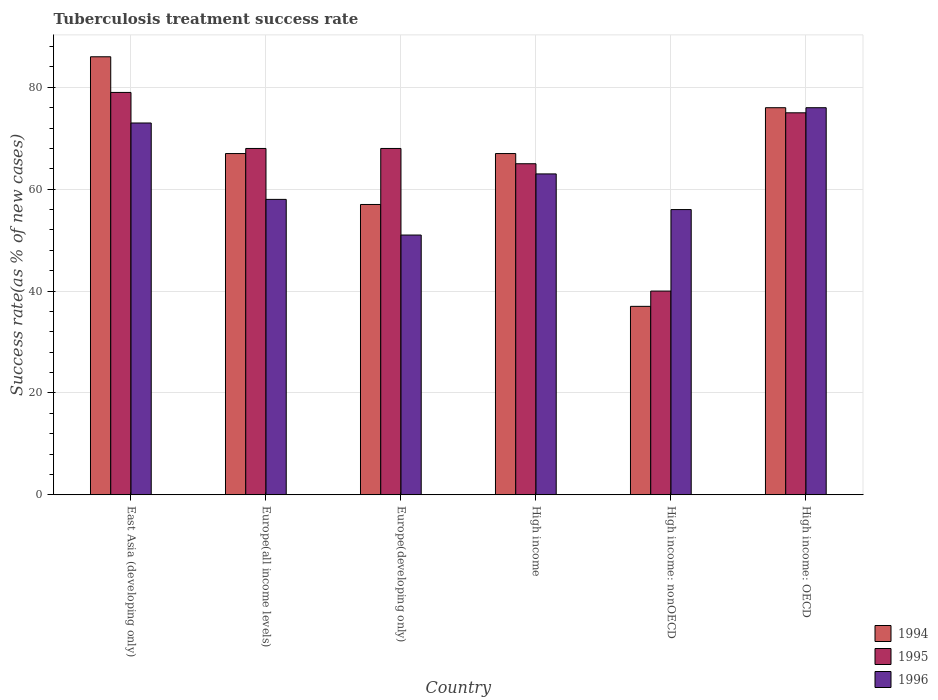How many different coloured bars are there?
Your response must be concise. 3. How many groups of bars are there?
Your response must be concise. 6. Are the number of bars per tick equal to the number of legend labels?
Your answer should be compact. Yes. What is the label of the 6th group of bars from the left?
Provide a short and direct response. High income: OECD. What is the tuberculosis treatment success rate in 1996 in Europe(all income levels)?
Give a very brief answer. 58. Across all countries, what is the maximum tuberculosis treatment success rate in 1994?
Offer a terse response. 86. Across all countries, what is the minimum tuberculosis treatment success rate in 1994?
Provide a short and direct response. 37. In which country was the tuberculosis treatment success rate in 1996 maximum?
Offer a very short reply. High income: OECD. In which country was the tuberculosis treatment success rate in 1996 minimum?
Offer a terse response. Europe(developing only). What is the total tuberculosis treatment success rate in 1996 in the graph?
Your response must be concise. 377. What is the difference between the tuberculosis treatment success rate in 1996 in Europe(all income levels) and that in High income: OECD?
Ensure brevity in your answer.  -18. What is the average tuberculosis treatment success rate in 1995 per country?
Your response must be concise. 65.83. What is the difference between the tuberculosis treatment success rate of/in 1996 and tuberculosis treatment success rate of/in 1994 in High income: OECD?
Make the answer very short. 0. What is the ratio of the tuberculosis treatment success rate in 1994 in East Asia (developing only) to that in High income: nonOECD?
Your response must be concise. 2.32. Is the tuberculosis treatment success rate in 1995 in East Asia (developing only) less than that in Europe(developing only)?
Give a very brief answer. No. In how many countries, is the tuberculosis treatment success rate in 1996 greater than the average tuberculosis treatment success rate in 1996 taken over all countries?
Your answer should be compact. 3. How many bars are there?
Your response must be concise. 18. What is the difference between two consecutive major ticks on the Y-axis?
Offer a terse response. 20. Does the graph contain grids?
Ensure brevity in your answer.  Yes. Where does the legend appear in the graph?
Make the answer very short. Bottom right. How many legend labels are there?
Offer a terse response. 3. What is the title of the graph?
Make the answer very short. Tuberculosis treatment success rate. Does "1964" appear as one of the legend labels in the graph?
Keep it short and to the point. No. What is the label or title of the X-axis?
Keep it short and to the point. Country. What is the label or title of the Y-axis?
Provide a short and direct response. Success rate(as % of new cases). What is the Success rate(as % of new cases) in 1994 in East Asia (developing only)?
Provide a succinct answer. 86. What is the Success rate(as % of new cases) in 1995 in East Asia (developing only)?
Offer a very short reply. 79. What is the Success rate(as % of new cases) in 1996 in East Asia (developing only)?
Your answer should be compact. 73. What is the Success rate(as % of new cases) in 1995 in Europe(all income levels)?
Offer a very short reply. 68. What is the Success rate(as % of new cases) in 1996 in Europe(all income levels)?
Keep it short and to the point. 58. What is the Success rate(as % of new cases) in 1994 in Europe(developing only)?
Offer a very short reply. 57. What is the Success rate(as % of new cases) of 1996 in Europe(developing only)?
Your response must be concise. 51. What is the Success rate(as % of new cases) of 1994 in High income?
Your answer should be very brief. 67. What is the Success rate(as % of new cases) in 1995 in High income?
Your response must be concise. 65. What is the Success rate(as % of new cases) of 1996 in High income?
Give a very brief answer. 63. What is the Success rate(as % of new cases) in 1994 in High income: nonOECD?
Keep it short and to the point. 37. What is the Success rate(as % of new cases) in 1996 in High income: nonOECD?
Provide a short and direct response. 56. What is the Success rate(as % of new cases) of 1995 in High income: OECD?
Ensure brevity in your answer.  75. Across all countries, what is the maximum Success rate(as % of new cases) of 1994?
Make the answer very short. 86. Across all countries, what is the maximum Success rate(as % of new cases) in 1995?
Your answer should be compact. 79. Across all countries, what is the maximum Success rate(as % of new cases) of 1996?
Make the answer very short. 76. Across all countries, what is the minimum Success rate(as % of new cases) of 1994?
Keep it short and to the point. 37. Across all countries, what is the minimum Success rate(as % of new cases) in 1995?
Your response must be concise. 40. Across all countries, what is the minimum Success rate(as % of new cases) of 1996?
Your answer should be very brief. 51. What is the total Success rate(as % of new cases) of 1994 in the graph?
Keep it short and to the point. 390. What is the total Success rate(as % of new cases) of 1995 in the graph?
Offer a very short reply. 395. What is the total Success rate(as % of new cases) in 1996 in the graph?
Ensure brevity in your answer.  377. What is the difference between the Success rate(as % of new cases) in 1994 in East Asia (developing only) and that in Europe(all income levels)?
Offer a terse response. 19. What is the difference between the Success rate(as % of new cases) of 1995 in East Asia (developing only) and that in Europe(all income levels)?
Your answer should be compact. 11. What is the difference between the Success rate(as % of new cases) in 1996 in East Asia (developing only) and that in Europe(developing only)?
Your response must be concise. 22. What is the difference between the Success rate(as % of new cases) of 1995 in East Asia (developing only) and that in High income?
Give a very brief answer. 14. What is the difference between the Success rate(as % of new cases) of 1996 in East Asia (developing only) and that in High income?
Provide a succinct answer. 10. What is the difference between the Success rate(as % of new cases) of 1996 in East Asia (developing only) and that in High income: nonOECD?
Keep it short and to the point. 17. What is the difference between the Success rate(as % of new cases) in 1995 in East Asia (developing only) and that in High income: OECD?
Give a very brief answer. 4. What is the difference between the Success rate(as % of new cases) of 1996 in East Asia (developing only) and that in High income: OECD?
Keep it short and to the point. -3. What is the difference between the Success rate(as % of new cases) of 1994 in Europe(all income levels) and that in Europe(developing only)?
Make the answer very short. 10. What is the difference between the Success rate(as % of new cases) in 1994 in Europe(all income levels) and that in High income?
Give a very brief answer. 0. What is the difference between the Success rate(as % of new cases) of 1995 in Europe(all income levels) and that in High income?
Your response must be concise. 3. What is the difference between the Success rate(as % of new cases) in 1994 in Europe(all income levels) and that in High income: nonOECD?
Your response must be concise. 30. What is the difference between the Success rate(as % of new cases) in 1996 in Europe(all income levels) and that in High income: OECD?
Provide a succinct answer. -18. What is the difference between the Success rate(as % of new cases) in 1996 in Europe(developing only) and that in High income?
Make the answer very short. -12. What is the difference between the Success rate(as % of new cases) of 1995 in Europe(developing only) and that in High income: OECD?
Ensure brevity in your answer.  -7. What is the difference between the Success rate(as % of new cases) of 1996 in Europe(developing only) and that in High income: OECD?
Offer a terse response. -25. What is the difference between the Success rate(as % of new cases) of 1994 in High income and that in High income: nonOECD?
Your answer should be very brief. 30. What is the difference between the Success rate(as % of new cases) in 1995 in High income and that in High income: nonOECD?
Your response must be concise. 25. What is the difference between the Success rate(as % of new cases) of 1996 in High income and that in High income: nonOECD?
Your answer should be very brief. 7. What is the difference between the Success rate(as % of new cases) in 1994 in High income and that in High income: OECD?
Your answer should be compact. -9. What is the difference between the Success rate(as % of new cases) in 1996 in High income and that in High income: OECD?
Offer a very short reply. -13. What is the difference between the Success rate(as % of new cases) of 1994 in High income: nonOECD and that in High income: OECD?
Provide a short and direct response. -39. What is the difference between the Success rate(as % of new cases) in 1995 in High income: nonOECD and that in High income: OECD?
Offer a terse response. -35. What is the difference between the Success rate(as % of new cases) of 1994 in East Asia (developing only) and the Success rate(as % of new cases) of 1995 in Europe(all income levels)?
Ensure brevity in your answer.  18. What is the difference between the Success rate(as % of new cases) of 1995 in East Asia (developing only) and the Success rate(as % of new cases) of 1996 in Europe(all income levels)?
Ensure brevity in your answer.  21. What is the difference between the Success rate(as % of new cases) in 1994 in East Asia (developing only) and the Success rate(as % of new cases) in 1996 in Europe(developing only)?
Keep it short and to the point. 35. What is the difference between the Success rate(as % of new cases) in 1995 in East Asia (developing only) and the Success rate(as % of new cases) in 1996 in Europe(developing only)?
Make the answer very short. 28. What is the difference between the Success rate(as % of new cases) of 1994 in East Asia (developing only) and the Success rate(as % of new cases) of 1996 in High income?
Make the answer very short. 23. What is the difference between the Success rate(as % of new cases) of 1995 in East Asia (developing only) and the Success rate(as % of new cases) of 1996 in High income?
Offer a terse response. 16. What is the difference between the Success rate(as % of new cases) of 1994 in East Asia (developing only) and the Success rate(as % of new cases) of 1996 in High income: nonOECD?
Your answer should be very brief. 30. What is the difference between the Success rate(as % of new cases) in 1994 in East Asia (developing only) and the Success rate(as % of new cases) in 1996 in High income: OECD?
Keep it short and to the point. 10. What is the difference between the Success rate(as % of new cases) in 1994 in Europe(all income levels) and the Success rate(as % of new cases) in 1995 in Europe(developing only)?
Your answer should be compact. -1. What is the difference between the Success rate(as % of new cases) of 1994 in Europe(all income levels) and the Success rate(as % of new cases) of 1996 in Europe(developing only)?
Offer a terse response. 16. What is the difference between the Success rate(as % of new cases) of 1995 in Europe(all income levels) and the Success rate(as % of new cases) of 1996 in Europe(developing only)?
Provide a short and direct response. 17. What is the difference between the Success rate(as % of new cases) in 1994 in Europe(all income levels) and the Success rate(as % of new cases) in 1995 in High income?
Make the answer very short. 2. What is the difference between the Success rate(as % of new cases) of 1994 in Europe(all income levels) and the Success rate(as % of new cases) of 1996 in High income?
Offer a terse response. 4. What is the difference between the Success rate(as % of new cases) in 1994 in Europe(all income levels) and the Success rate(as % of new cases) in 1995 in High income: nonOECD?
Your response must be concise. 27. What is the difference between the Success rate(as % of new cases) of 1994 in Europe(all income levels) and the Success rate(as % of new cases) of 1996 in High income: nonOECD?
Provide a short and direct response. 11. What is the difference between the Success rate(as % of new cases) of 1995 in Europe(all income levels) and the Success rate(as % of new cases) of 1996 in High income: nonOECD?
Ensure brevity in your answer.  12. What is the difference between the Success rate(as % of new cases) in 1994 in Europe(all income levels) and the Success rate(as % of new cases) in 1995 in High income: OECD?
Your answer should be compact. -8. What is the difference between the Success rate(as % of new cases) in 1994 in Europe(all income levels) and the Success rate(as % of new cases) in 1996 in High income: OECD?
Your response must be concise. -9. What is the difference between the Success rate(as % of new cases) in 1994 in Europe(developing only) and the Success rate(as % of new cases) in 1996 in High income?
Keep it short and to the point. -6. What is the difference between the Success rate(as % of new cases) in 1994 in Europe(developing only) and the Success rate(as % of new cases) in 1995 in High income: OECD?
Your answer should be very brief. -18. What is the difference between the Success rate(as % of new cases) of 1994 in Europe(developing only) and the Success rate(as % of new cases) of 1996 in High income: OECD?
Ensure brevity in your answer.  -19. What is the difference between the Success rate(as % of new cases) in 1995 in Europe(developing only) and the Success rate(as % of new cases) in 1996 in High income: OECD?
Give a very brief answer. -8. What is the difference between the Success rate(as % of new cases) in 1994 in High income and the Success rate(as % of new cases) in 1996 in High income: OECD?
Make the answer very short. -9. What is the difference between the Success rate(as % of new cases) in 1995 in High income and the Success rate(as % of new cases) in 1996 in High income: OECD?
Offer a terse response. -11. What is the difference between the Success rate(as % of new cases) of 1994 in High income: nonOECD and the Success rate(as % of new cases) of 1995 in High income: OECD?
Provide a short and direct response. -38. What is the difference between the Success rate(as % of new cases) in 1994 in High income: nonOECD and the Success rate(as % of new cases) in 1996 in High income: OECD?
Provide a succinct answer. -39. What is the difference between the Success rate(as % of new cases) in 1995 in High income: nonOECD and the Success rate(as % of new cases) in 1996 in High income: OECD?
Keep it short and to the point. -36. What is the average Success rate(as % of new cases) of 1994 per country?
Keep it short and to the point. 65. What is the average Success rate(as % of new cases) of 1995 per country?
Your answer should be compact. 65.83. What is the average Success rate(as % of new cases) in 1996 per country?
Give a very brief answer. 62.83. What is the difference between the Success rate(as % of new cases) of 1994 and Success rate(as % of new cases) of 1995 in East Asia (developing only)?
Offer a terse response. 7. What is the difference between the Success rate(as % of new cases) of 1994 and Success rate(as % of new cases) of 1996 in East Asia (developing only)?
Provide a succinct answer. 13. What is the difference between the Success rate(as % of new cases) in 1994 and Success rate(as % of new cases) in 1996 in Europe(all income levels)?
Offer a very short reply. 9. What is the difference between the Success rate(as % of new cases) of 1995 and Success rate(as % of new cases) of 1996 in Europe(developing only)?
Your response must be concise. 17. What is the difference between the Success rate(as % of new cases) of 1995 and Success rate(as % of new cases) of 1996 in High income?
Make the answer very short. 2. What is the difference between the Success rate(as % of new cases) in 1994 and Success rate(as % of new cases) in 1996 in High income: nonOECD?
Provide a succinct answer. -19. What is the difference between the Success rate(as % of new cases) of 1994 and Success rate(as % of new cases) of 1995 in High income: OECD?
Your answer should be very brief. 1. What is the difference between the Success rate(as % of new cases) of 1994 and Success rate(as % of new cases) of 1996 in High income: OECD?
Make the answer very short. 0. What is the difference between the Success rate(as % of new cases) of 1995 and Success rate(as % of new cases) of 1996 in High income: OECD?
Offer a very short reply. -1. What is the ratio of the Success rate(as % of new cases) of 1994 in East Asia (developing only) to that in Europe(all income levels)?
Give a very brief answer. 1.28. What is the ratio of the Success rate(as % of new cases) of 1995 in East Asia (developing only) to that in Europe(all income levels)?
Make the answer very short. 1.16. What is the ratio of the Success rate(as % of new cases) of 1996 in East Asia (developing only) to that in Europe(all income levels)?
Give a very brief answer. 1.26. What is the ratio of the Success rate(as % of new cases) of 1994 in East Asia (developing only) to that in Europe(developing only)?
Give a very brief answer. 1.51. What is the ratio of the Success rate(as % of new cases) in 1995 in East Asia (developing only) to that in Europe(developing only)?
Ensure brevity in your answer.  1.16. What is the ratio of the Success rate(as % of new cases) of 1996 in East Asia (developing only) to that in Europe(developing only)?
Offer a terse response. 1.43. What is the ratio of the Success rate(as % of new cases) in 1994 in East Asia (developing only) to that in High income?
Offer a terse response. 1.28. What is the ratio of the Success rate(as % of new cases) in 1995 in East Asia (developing only) to that in High income?
Offer a very short reply. 1.22. What is the ratio of the Success rate(as % of new cases) of 1996 in East Asia (developing only) to that in High income?
Give a very brief answer. 1.16. What is the ratio of the Success rate(as % of new cases) of 1994 in East Asia (developing only) to that in High income: nonOECD?
Keep it short and to the point. 2.32. What is the ratio of the Success rate(as % of new cases) in 1995 in East Asia (developing only) to that in High income: nonOECD?
Offer a very short reply. 1.98. What is the ratio of the Success rate(as % of new cases) of 1996 in East Asia (developing only) to that in High income: nonOECD?
Your answer should be compact. 1.3. What is the ratio of the Success rate(as % of new cases) in 1994 in East Asia (developing only) to that in High income: OECD?
Your response must be concise. 1.13. What is the ratio of the Success rate(as % of new cases) of 1995 in East Asia (developing only) to that in High income: OECD?
Offer a very short reply. 1.05. What is the ratio of the Success rate(as % of new cases) of 1996 in East Asia (developing only) to that in High income: OECD?
Keep it short and to the point. 0.96. What is the ratio of the Success rate(as % of new cases) of 1994 in Europe(all income levels) to that in Europe(developing only)?
Your response must be concise. 1.18. What is the ratio of the Success rate(as % of new cases) in 1995 in Europe(all income levels) to that in Europe(developing only)?
Offer a very short reply. 1. What is the ratio of the Success rate(as % of new cases) of 1996 in Europe(all income levels) to that in Europe(developing only)?
Offer a very short reply. 1.14. What is the ratio of the Success rate(as % of new cases) in 1995 in Europe(all income levels) to that in High income?
Make the answer very short. 1.05. What is the ratio of the Success rate(as % of new cases) of 1996 in Europe(all income levels) to that in High income?
Give a very brief answer. 0.92. What is the ratio of the Success rate(as % of new cases) of 1994 in Europe(all income levels) to that in High income: nonOECD?
Your answer should be very brief. 1.81. What is the ratio of the Success rate(as % of new cases) of 1995 in Europe(all income levels) to that in High income: nonOECD?
Your answer should be very brief. 1.7. What is the ratio of the Success rate(as % of new cases) of 1996 in Europe(all income levels) to that in High income: nonOECD?
Provide a succinct answer. 1.04. What is the ratio of the Success rate(as % of new cases) of 1994 in Europe(all income levels) to that in High income: OECD?
Offer a very short reply. 0.88. What is the ratio of the Success rate(as % of new cases) of 1995 in Europe(all income levels) to that in High income: OECD?
Keep it short and to the point. 0.91. What is the ratio of the Success rate(as % of new cases) of 1996 in Europe(all income levels) to that in High income: OECD?
Offer a very short reply. 0.76. What is the ratio of the Success rate(as % of new cases) in 1994 in Europe(developing only) to that in High income?
Ensure brevity in your answer.  0.85. What is the ratio of the Success rate(as % of new cases) of 1995 in Europe(developing only) to that in High income?
Keep it short and to the point. 1.05. What is the ratio of the Success rate(as % of new cases) of 1996 in Europe(developing only) to that in High income?
Keep it short and to the point. 0.81. What is the ratio of the Success rate(as % of new cases) of 1994 in Europe(developing only) to that in High income: nonOECD?
Your answer should be compact. 1.54. What is the ratio of the Success rate(as % of new cases) in 1996 in Europe(developing only) to that in High income: nonOECD?
Provide a short and direct response. 0.91. What is the ratio of the Success rate(as % of new cases) in 1995 in Europe(developing only) to that in High income: OECD?
Make the answer very short. 0.91. What is the ratio of the Success rate(as % of new cases) in 1996 in Europe(developing only) to that in High income: OECD?
Offer a terse response. 0.67. What is the ratio of the Success rate(as % of new cases) of 1994 in High income to that in High income: nonOECD?
Your answer should be very brief. 1.81. What is the ratio of the Success rate(as % of new cases) of 1995 in High income to that in High income: nonOECD?
Your response must be concise. 1.62. What is the ratio of the Success rate(as % of new cases) of 1994 in High income to that in High income: OECD?
Ensure brevity in your answer.  0.88. What is the ratio of the Success rate(as % of new cases) in 1995 in High income to that in High income: OECD?
Offer a terse response. 0.87. What is the ratio of the Success rate(as % of new cases) in 1996 in High income to that in High income: OECD?
Offer a terse response. 0.83. What is the ratio of the Success rate(as % of new cases) in 1994 in High income: nonOECD to that in High income: OECD?
Your response must be concise. 0.49. What is the ratio of the Success rate(as % of new cases) of 1995 in High income: nonOECD to that in High income: OECD?
Keep it short and to the point. 0.53. What is the ratio of the Success rate(as % of new cases) of 1996 in High income: nonOECD to that in High income: OECD?
Provide a succinct answer. 0.74. What is the difference between the highest and the lowest Success rate(as % of new cases) of 1994?
Your answer should be very brief. 49. What is the difference between the highest and the lowest Success rate(as % of new cases) of 1995?
Your answer should be very brief. 39. What is the difference between the highest and the lowest Success rate(as % of new cases) of 1996?
Give a very brief answer. 25. 